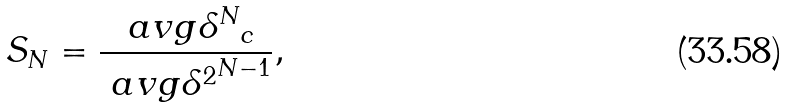<formula> <loc_0><loc_0><loc_500><loc_500>S _ { N } = \frac { \ a v g { \delta ^ { N } } _ { c } } { \ a v g { \delta ^ { 2 } } ^ { N - 1 } } ,</formula> 